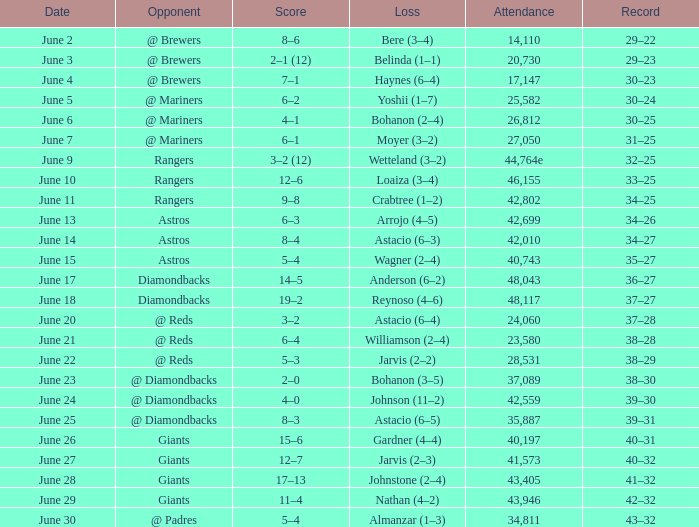When the attendance reached 41,573, what was the record? 40–32. 